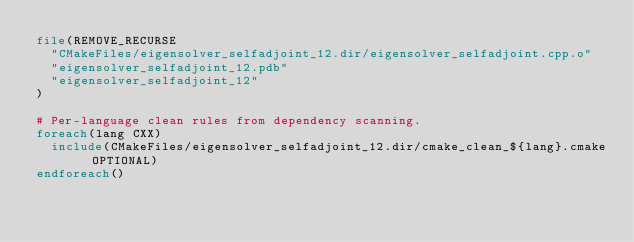Convert code to text. <code><loc_0><loc_0><loc_500><loc_500><_CMake_>file(REMOVE_RECURSE
  "CMakeFiles/eigensolver_selfadjoint_12.dir/eigensolver_selfadjoint.cpp.o"
  "eigensolver_selfadjoint_12.pdb"
  "eigensolver_selfadjoint_12"
)

# Per-language clean rules from dependency scanning.
foreach(lang CXX)
  include(CMakeFiles/eigensolver_selfadjoint_12.dir/cmake_clean_${lang}.cmake OPTIONAL)
endforeach()
</code> 